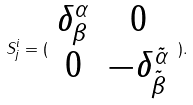Convert formula to latex. <formula><loc_0><loc_0><loc_500><loc_500>S _ { j } ^ { i } = ( \begin{array} { c c } \delta _ { \beta } ^ { \alpha } & 0 \\ 0 & - \delta _ { \tilde { \beta } } ^ { \tilde { \alpha } } \end{array} ) .</formula> 